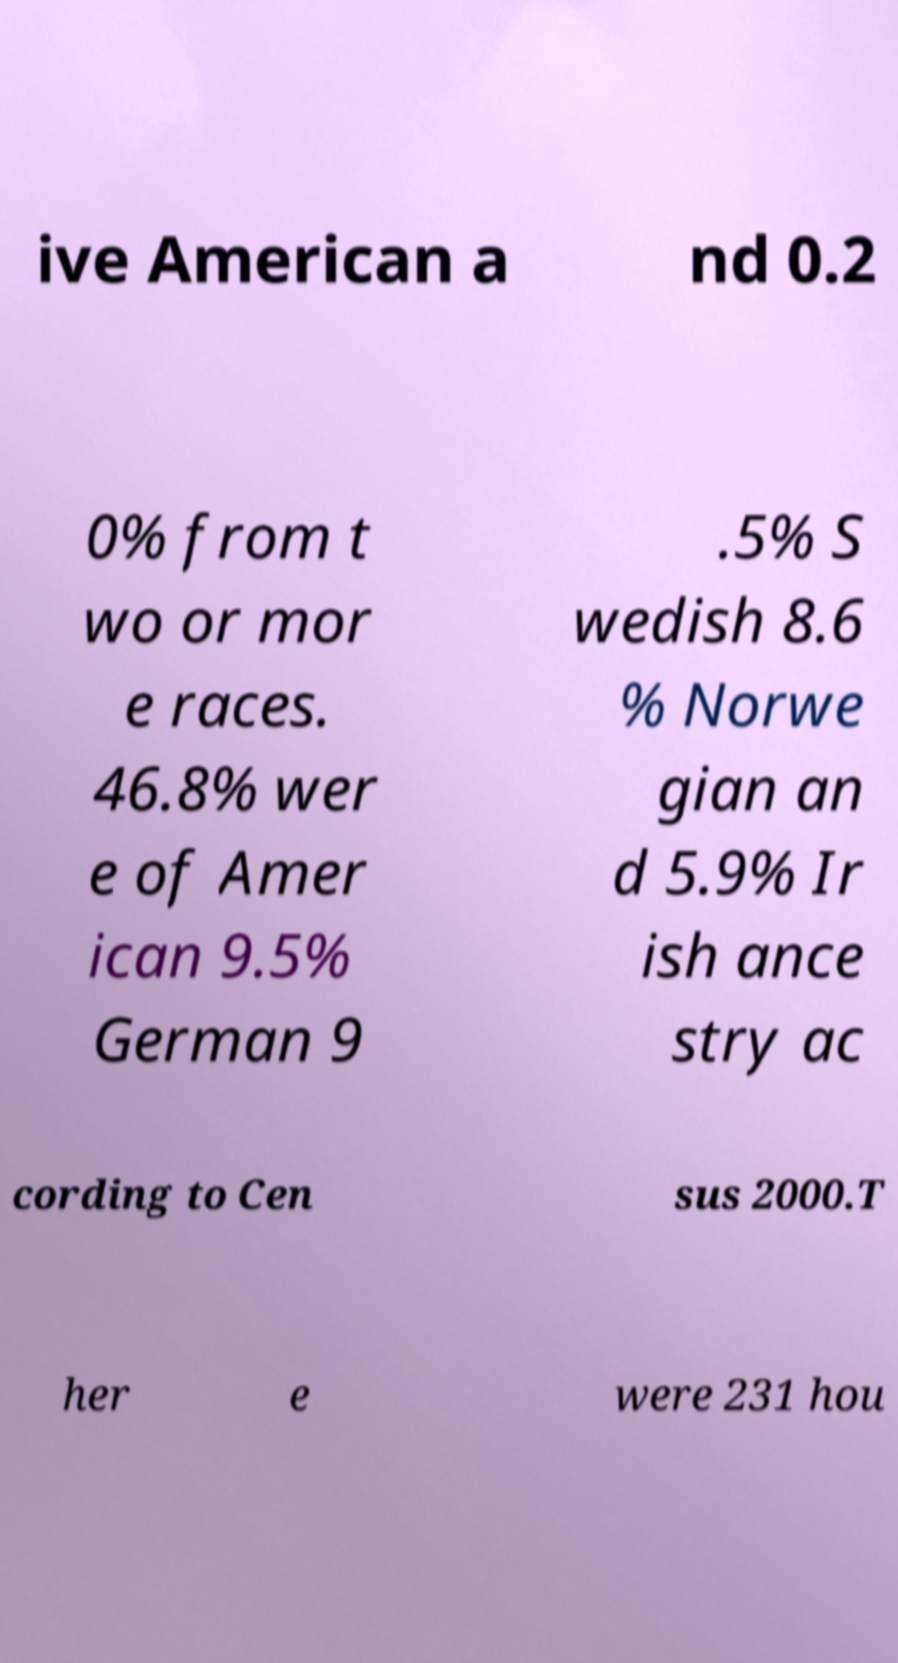There's text embedded in this image that I need extracted. Can you transcribe it verbatim? ive American a nd 0.2 0% from t wo or mor e races. 46.8% wer e of Amer ican 9.5% German 9 .5% S wedish 8.6 % Norwe gian an d 5.9% Ir ish ance stry ac cording to Cen sus 2000.T her e were 231 hou 